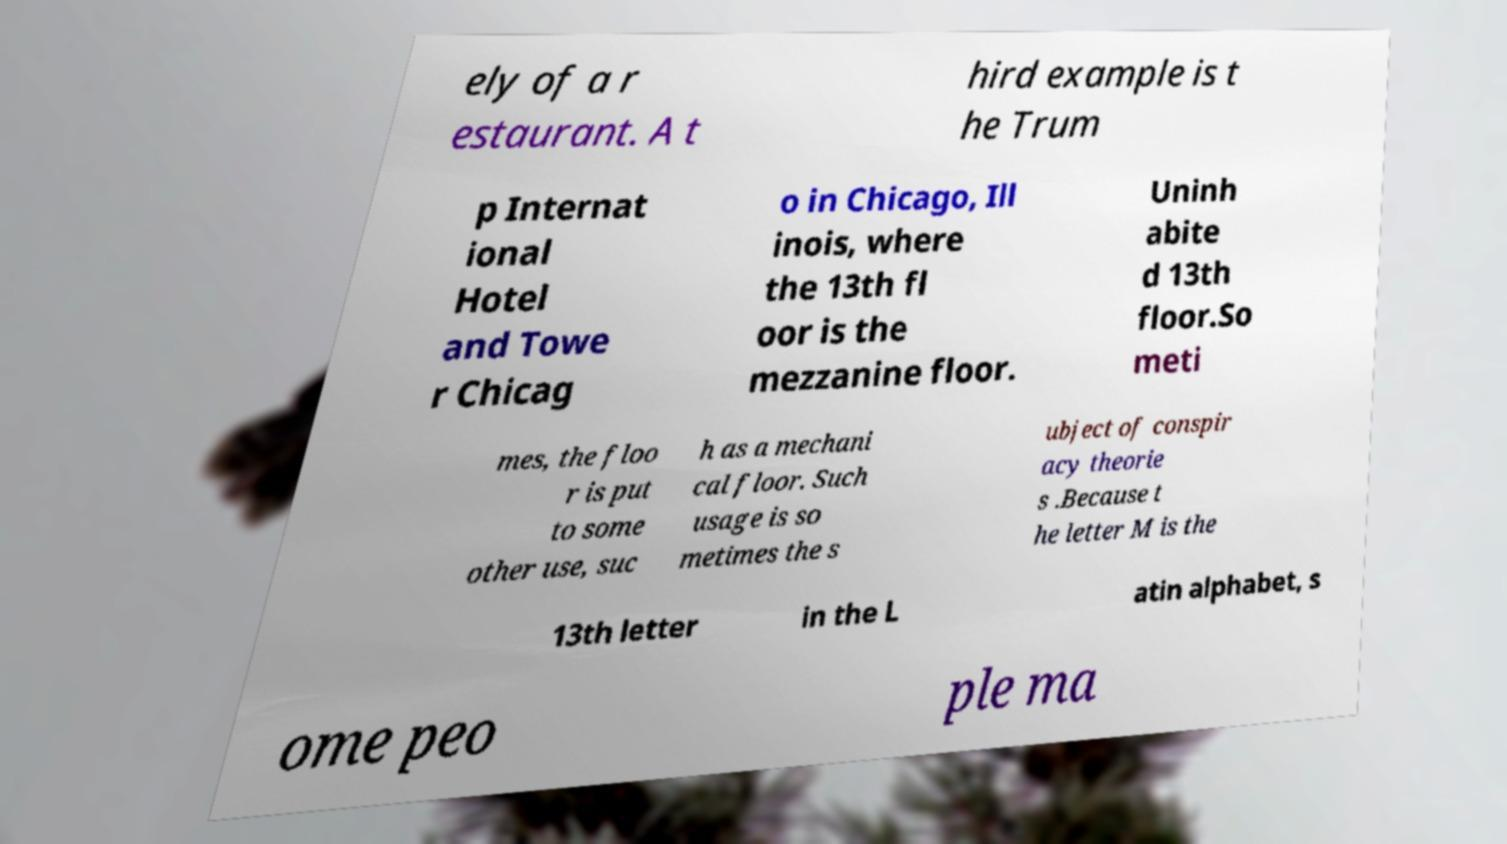Please read and relay the text visible in this image. What does it say? ely of a r estaurant. A t hird example is t he Trum p Internat ional Hotel and Towe r Chicag o in Chicago, Ill inois, where the 13th fl oor is the mezzanine floor. Uninh abite d 13th floor.So meti mes, the floo r is put to some other use, suc h as a mechani cal floor. Such usage is so metimes the s ubject of conspir acy theorie s .Because t he letter M is the 13th letter in the L atin alphabet, s ome peo ple ma 